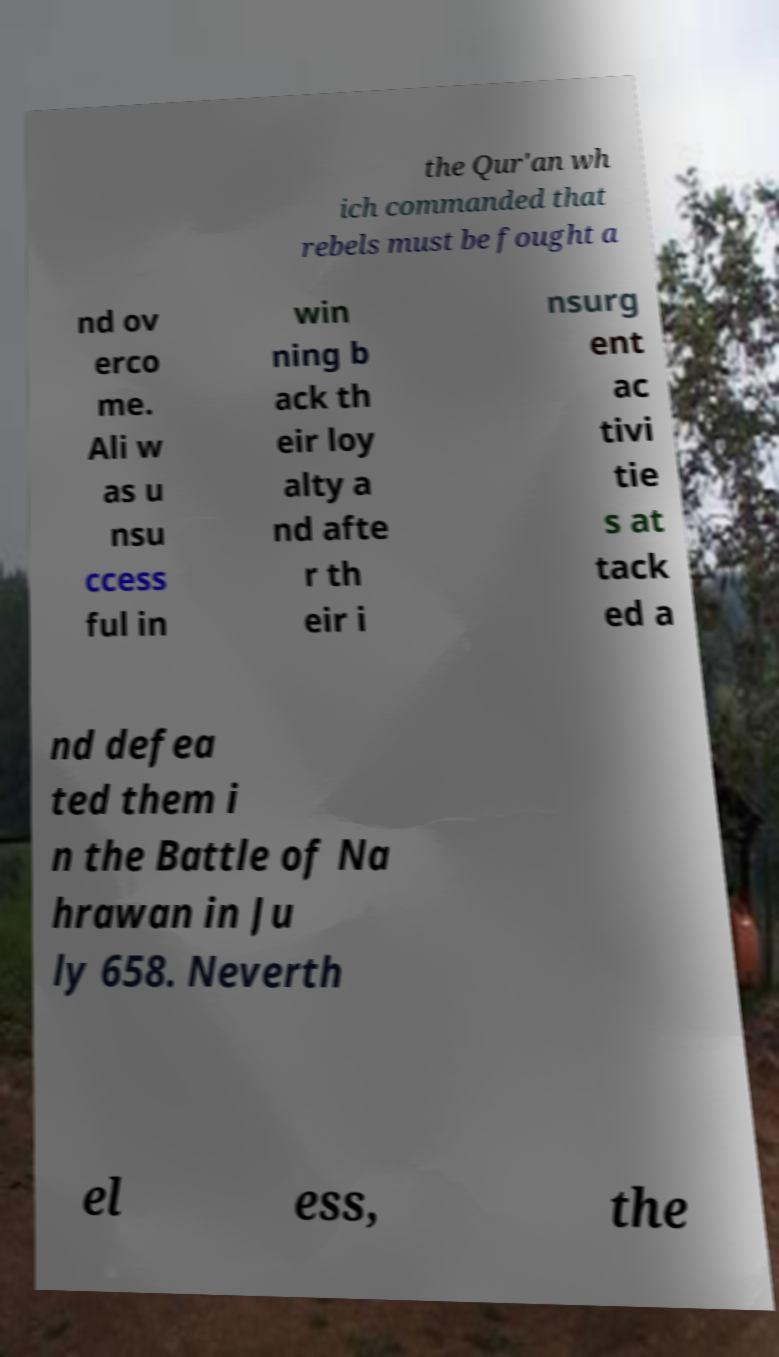For documentation purposes, I need the text within this image transcribed. Could you provide that? the Qur'an wh ich commanded that rebels must be fought a nd ov erco me. Ali w as u nsu ccess ful in win ning b ack th eir loy alty a nd afte r th eir i nsurg ent ac tivi tie s at tack ed a nd defea ted them i n the Battle of Na hrawan in Ju ly 658. Neverth el ess, the 